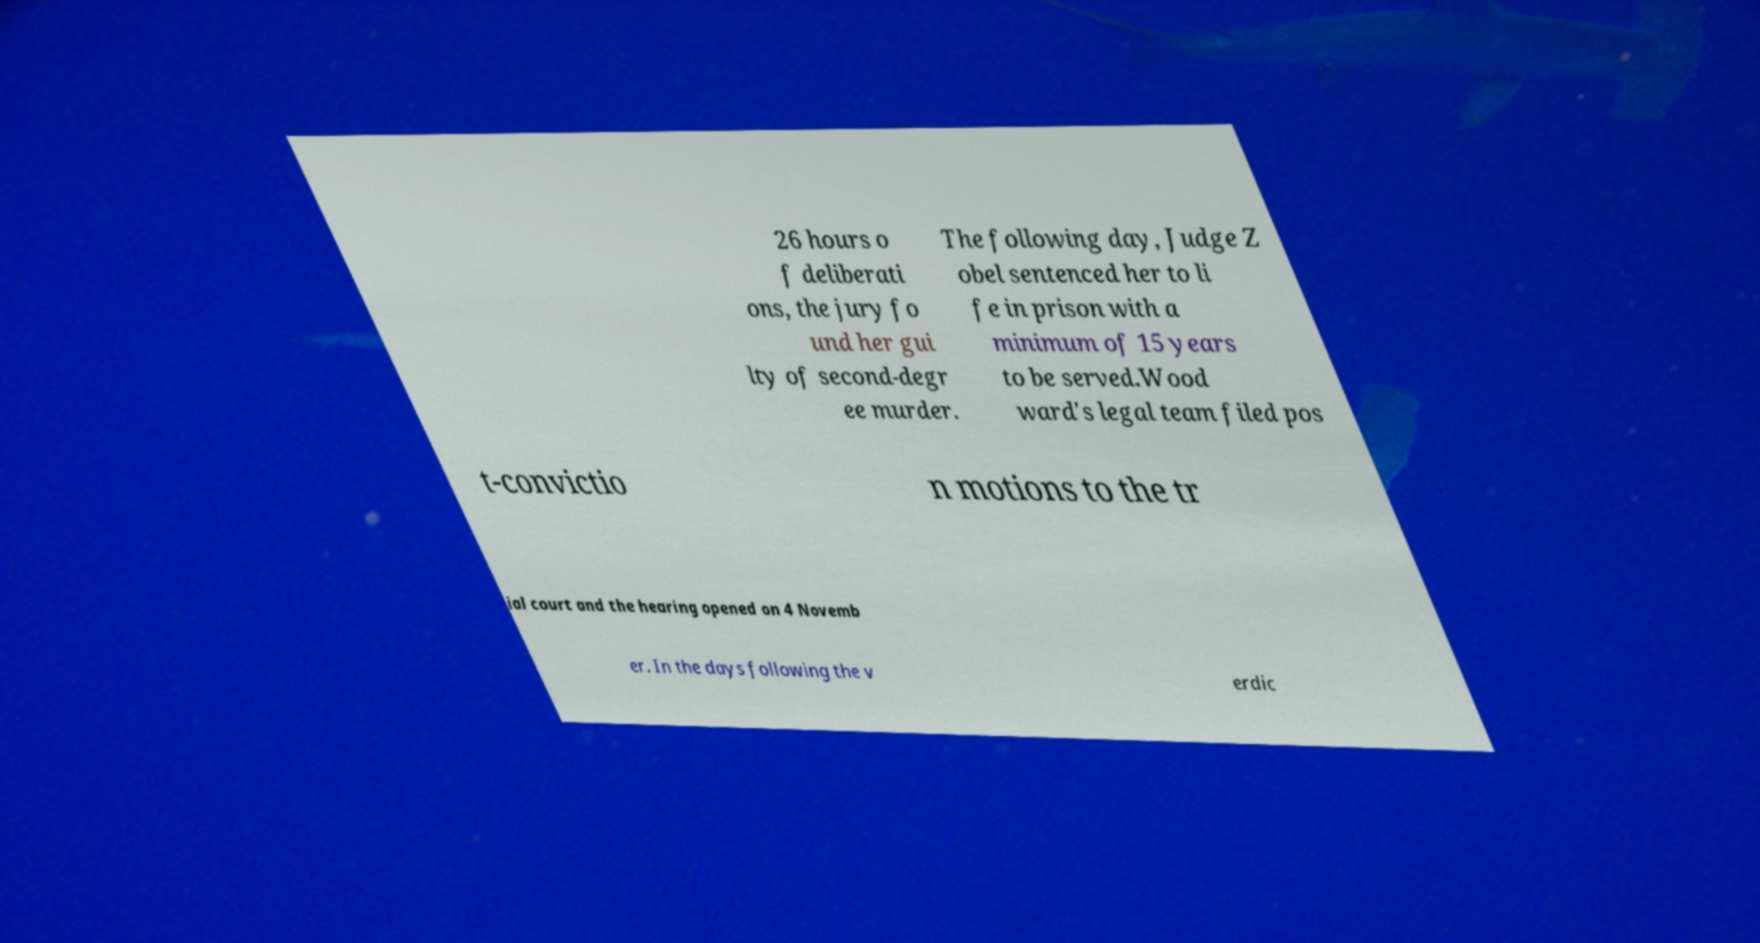Can you read and provide the text displayed in the image?This photo seems to have some interesting text. Can you extract and type it out for me? 26 hours o f deliberati ons, the jury fo und her gui lty of second-degr ee murder. The following day, Judge Z obel sentenced her to li fe in prison with a minimum of 15 years to be served.Wood ward's legal team filed pos t-convictio n motions to the tr ial court and the hearing opened on 4 Novemb er. In the days following the v erdic 